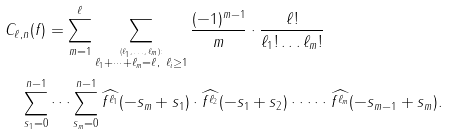Convert formula to latex. <formula><loc_0><loc_0><loc_500><loc_500>& C _ { \ell , n } ( f ) = \sum ^ { \ell } _ { m = 1 } \sum _ { \stackrel { \text { $(\ell_{1},\dots ,\ell_{m})\colon$} } { \ell _ { 1 } + \dots + \ell _ { m } = \ell , \ \ell _ { i } \geq 1 } } \frac { ( - 1 ) ^ { m - 1 } } { m } \cdot \frac { \ell ! } { \ell _ { 1 } ! \dots \ell _ { m } ! } \\ & \quad \sum ^ { n - 1 } _ { s _ { 1 } = 0 } \dots \sum ^ { n - 1 } _ { s _ { m } = 0 } \widehat { f ^ { \ell _ { 1 } } } ( - s _ { m } + s _ { 1 } ) \cdot \widehat { f ^ { \ell _ { 2 } } } ( - s _ { 1 } + s _ { 2 } ) \cdot \dots \cdot \widehat { f ^ { \ell _ { m } } } ( - s _ { m - 1 } + s _ { m } ) .</formula> 